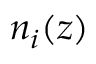Convert formula to latex. <formula><loc_0><loc_0><loc_500><loc_500>n _ { i } ( z )</formula> 